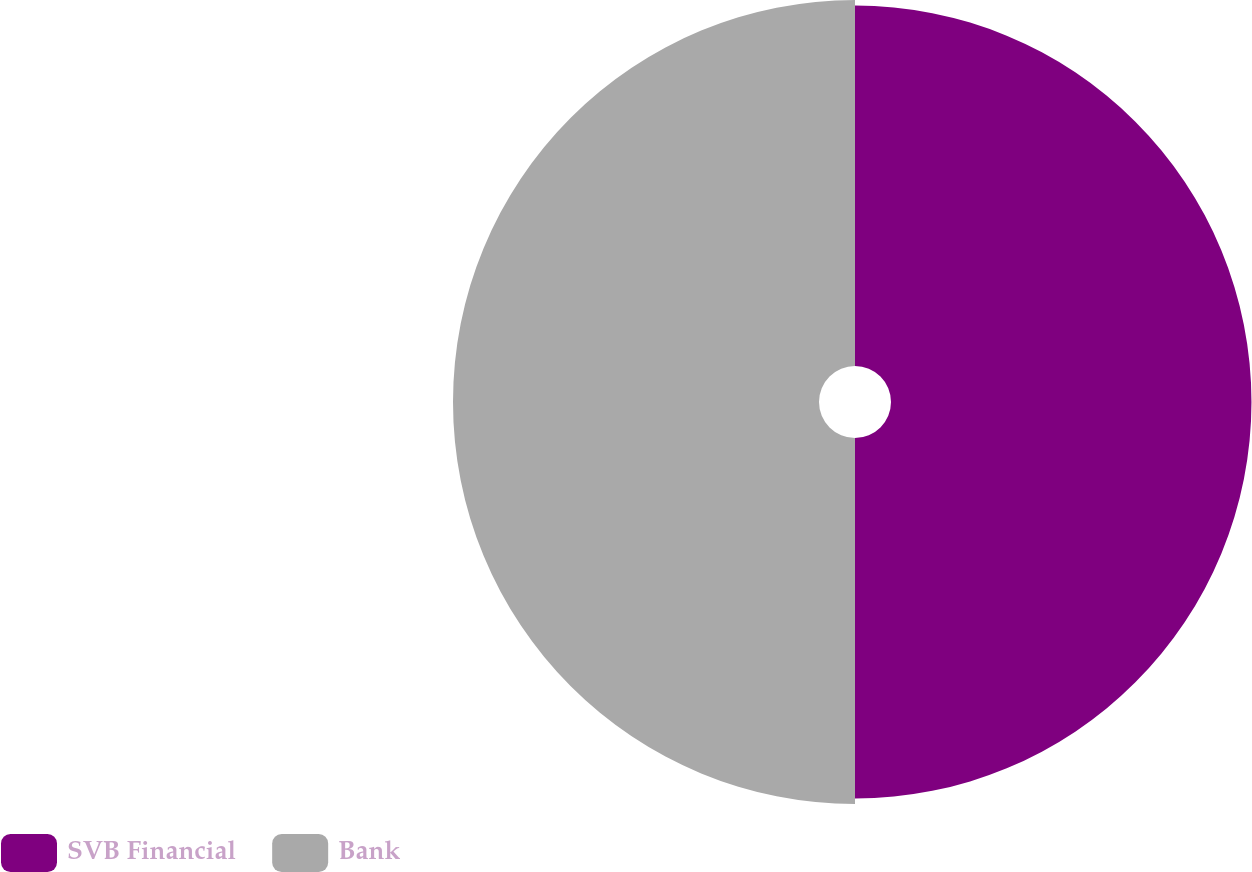Convert chart to OTSL. <chart><loc_0><loc_0><loc_500><loc_500><pie_chart><fcel>SVB Financial<fcel>Bank<nl><fcel>49.62%<fcel>50.38%<nl></chart> 